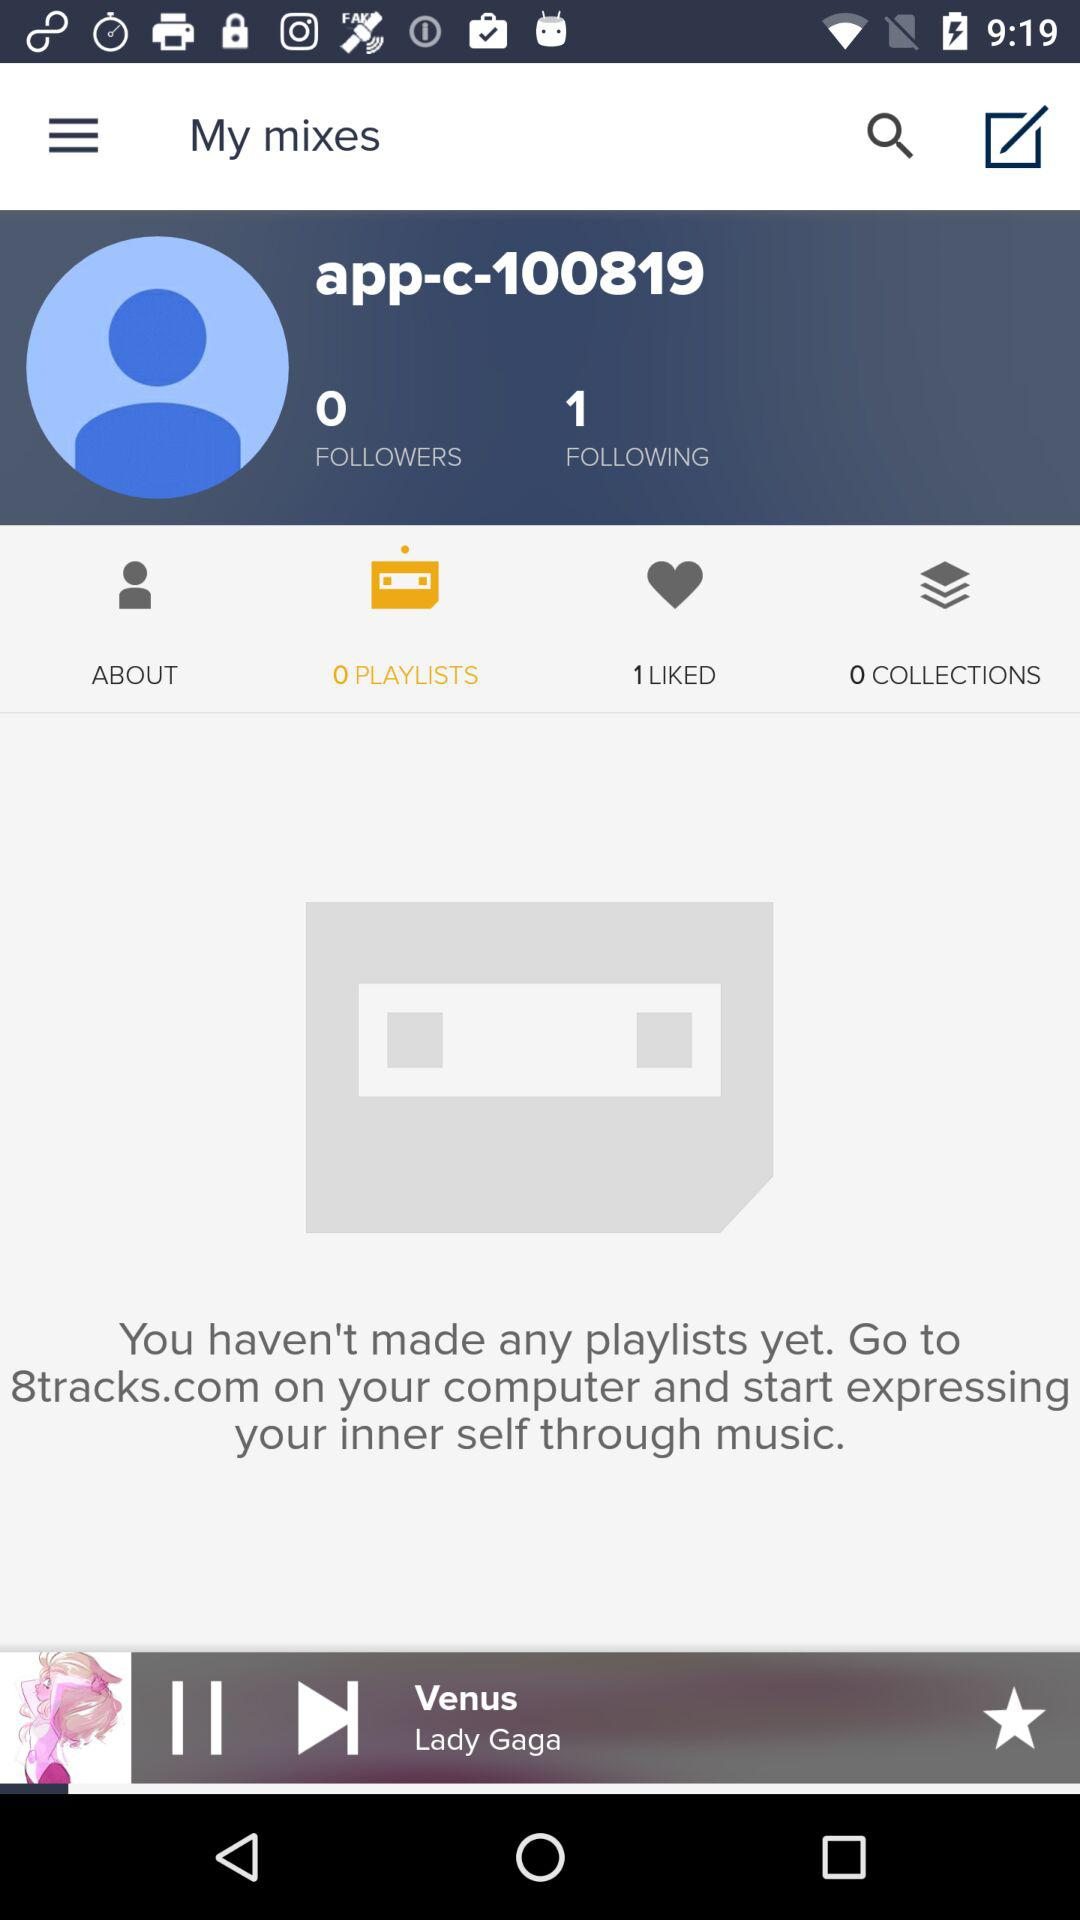How many people does the user follow? The number of people that the user follows is 1. 